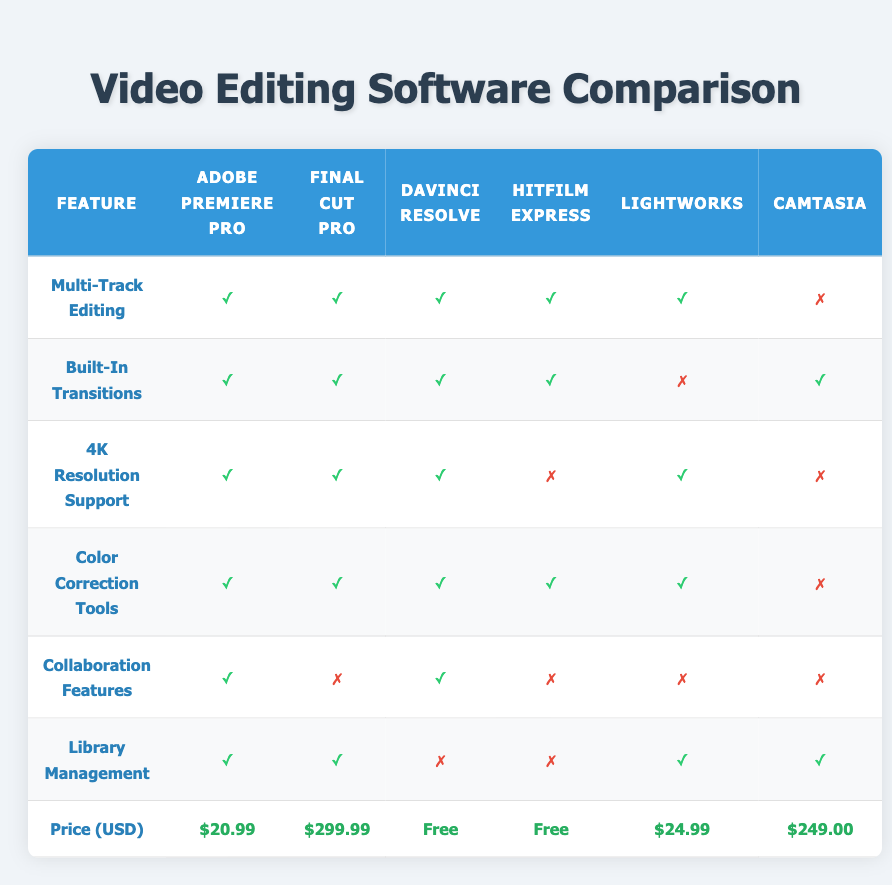What video editing software has the highest price? The prices for the software are: Adobe Premiere Pro ($20.99), Final Cut Pro ($299.99), DaVinci Resolve (Free), HitFilm Express (Free), Lightworks ($24.99), and Camtasia ($249.00). The highest price among these is for Final Cut Pro at $299.99.
Answer: Final Cut Pro Which software does not support 4K resolution? Looking at the '4K Resolution Support' row, HitFilm Express and Camtasia are marked with a "✗", indicating they do not support 4K resolution.
Answer: HitFilm Express and Camtasia How many software options have built-in transitions? Checking the 'Built-In Transitions' row, all software except Lightworks support built-in transitions, indicated by "✓". Since there are 5 software listed and 4 support built-in transitions, this means 4 options have this feature.
Answer: 4 Does DaVinci Resolve offer collaboration features? Referring to the 'Collaboration Features' row, DaVinci Resolve is marked with a "✓", meaning it does offer collaboration features.
Answer: Yes What is the mode price of the software listed? The prices are as follows: $20.99, $299.99, Free, Free, $24.99, and $249.00. The mode is the most frequently occurring value among these. Here, 'Free' appears twice, while all other values appear once. Therefore, the mode price is Free.
Answer: Free Which software has the most features? To determine the software with the most features, we can add the number of "✓" (features present) in each row for all software. Adobe Premiere Pro has 6 features, Final Cut Pro has 5, DaVinci Resolve has 5, HitFilm Express has 4, Lightworks has 5, and Camtasia has 3. Therefore, Adobe Premiere Pro has the most features.
Answer: Adobe Premiere Pro How much more expensive is Final Cut Pro compared to Adobe Premiere Pro? The price of Final Cut Pro is $299.99 and the price of Adobe Premiere Pro is $20.99. To find how much more expensive Final Cut Pro is, subtract the price of Adobe Premiere Pro from that of Final Cut Pro: $299.99 - $20.99 = $279.00.
Answer: $279.00 Is it true that all software support multi-track editing? Looking at the 'Multi-Track Editing' row, all software except Camtasia are marked with a "✓", meaning they do support multi-track editing. Thus, it is not true that all software support this feature.
Answer: No 